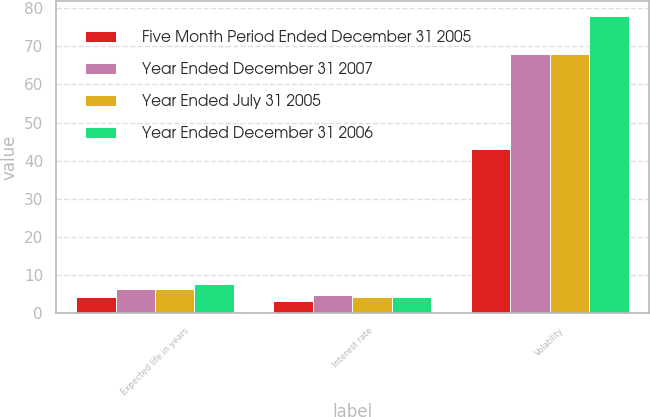Convert chart. <chart><loc_0><loc_0><loc_500><loc_500><stacked_bar_chart><ecel><fcel>Expected life in years<fcel>Interest rate<fcel>Volatility<nl><fcel>Five Month Period Ended December 31 2005<fcel>4.28<fcel>3.1<fcel>43<nl><fcel>Year Ended December 31 2007<fcel>6.25<fcel>4.7<fcel>68<nl><fcel>Year Ended July 31 2005<fcel>6.25<fcel>4.3<fcel>68<nl><fcel>Year Ended December 31 2006<fcel>7.5<fcel>4.1<fcel>78<nl></chart> 